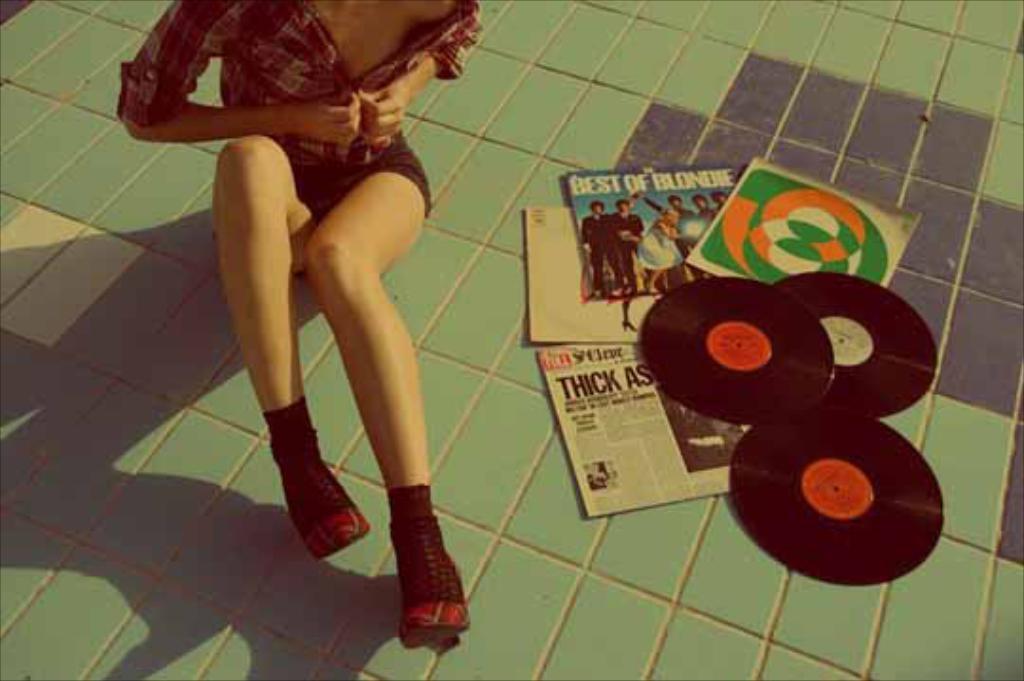Please provide a concise description of this image. In this image in the center there is one woman who is sitting beside her there are some books and dvds, at the bottom there is a walkway. 